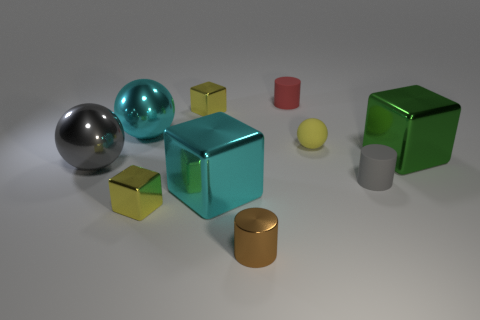Subtract all yellow cubes. How many cubes are left? 2 Subtract all rubber cylinders. How many cylinders are left? 1 Subtract all blocks. How many objects are left? 6 Subtract 1 blocks. How many blocks are left? 3 Subtract all cyan cylinders. Subtract all brown spheres. How many cylinders are left? 3 Subtract all brown cubes. How many red cylinders are left? 1 Subtract all tiny red cylinders. Subtract all cylinders. How many objects are left? 6 Add 9 shiny cylinders. How many shiny cylinders are left? 10 Add 9 red rubber cylinders. How many red rubber cylinders exist? 10 Subtract 0 gray blocks. How many objects are left? 10 